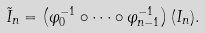<formula> <loc_0><loc_0><loc_500><loc_500>\tilde { I } _ { n } = \left ( \varphi _ { 0 } ^ { - 1 } \circ \cdots \circ \varphi _ { n - 1 } ^ { - 1 } \right ) ( I _ { n } ) .</formula> 